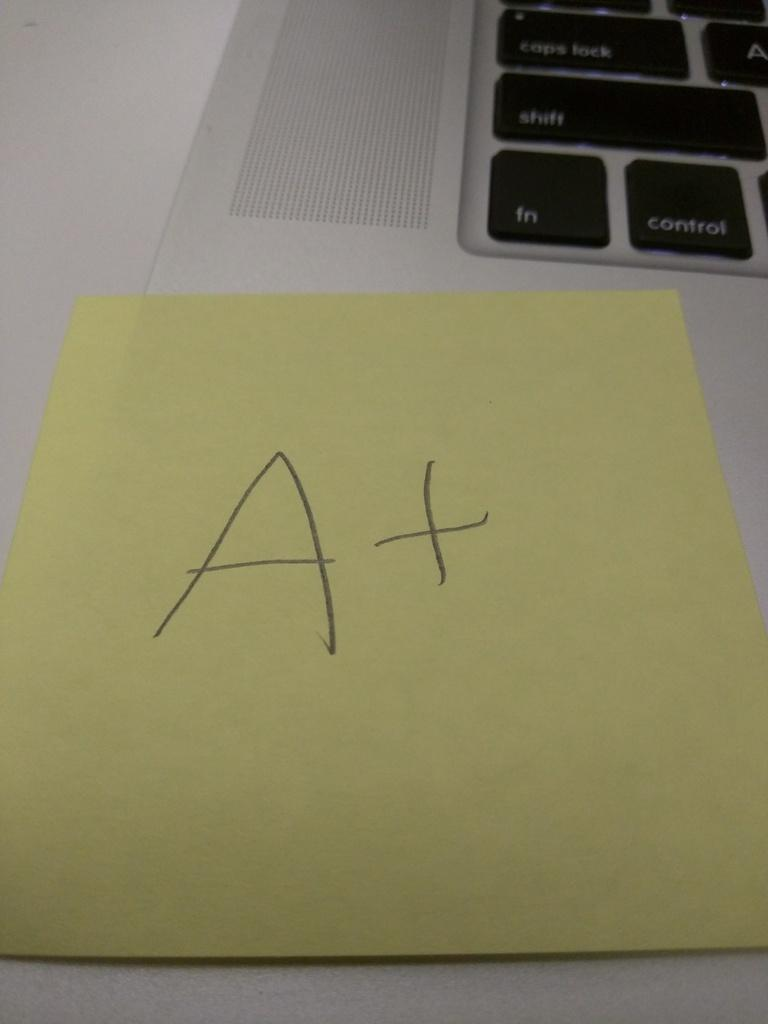<image>
Summarize the visual content of the image. A sticky note that says A+ stuck onto a macbook. 